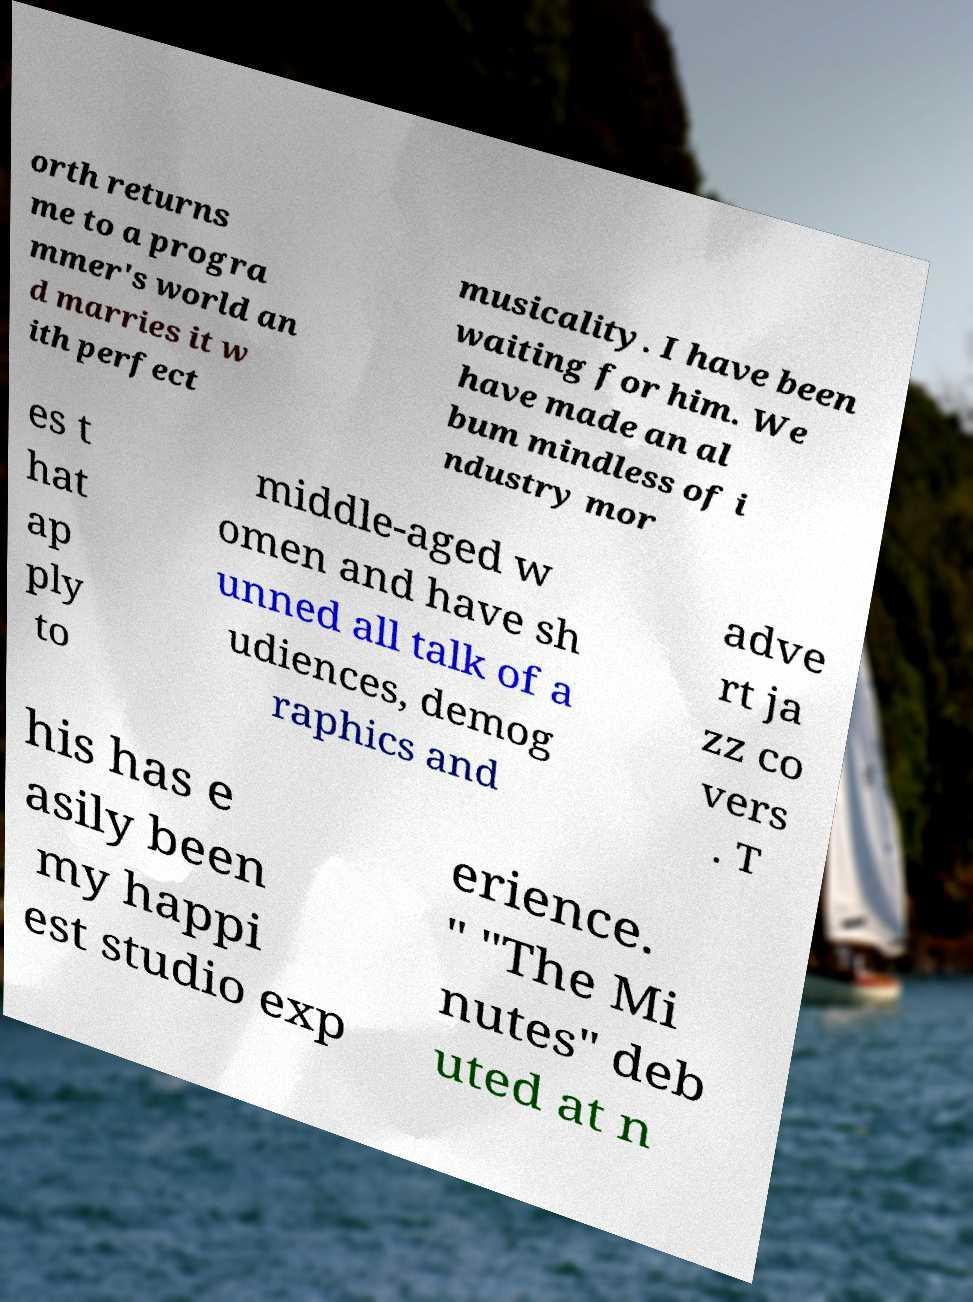I need the written content from this picture converted into text. Can you do that? orth returns me to a progra mmer's world an d marries it w ith perfect musicality. I have been waiting for him. We have made an al bum mindless of i ndustry mor es t hat ap ply to middle-aged w omen and have sh unned all talk of a udiences, demog raphics and adve rt ja zz co vers . T his has e asily been my happi est studio exp erience. " "The Mi nutes" deb uted at n 